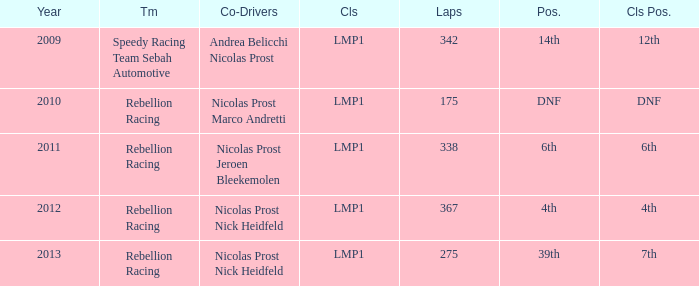What is class position, when year is pre-2013, and when laps surpass 175? 12th, 6th, 4th. 